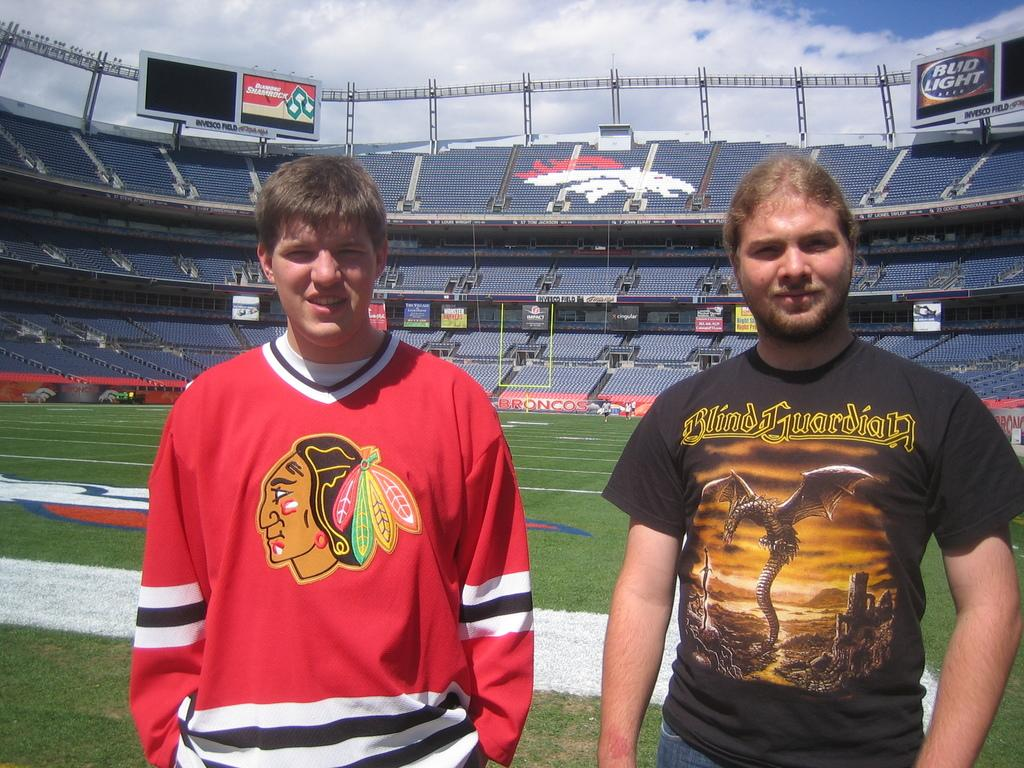<image>
Relay a brief, clear account of the picture shown. A man in a Blind Guardian t-shirt stands on a sports field. 